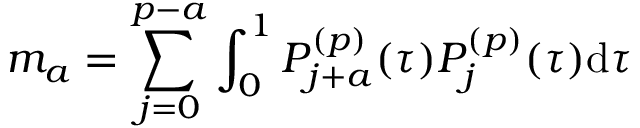<formula> <loc_0><loc_0><loc_500><loc_500>m _ { a } = \sum _ { j = 0 } ^ { p - a } \int _ { 0 } ^ { 1 } P _ { j + a } ^ { ( p ) } ( \tau ) P _ { j } ^ { ( p ) } ( \tau ) d \tau</formula> 